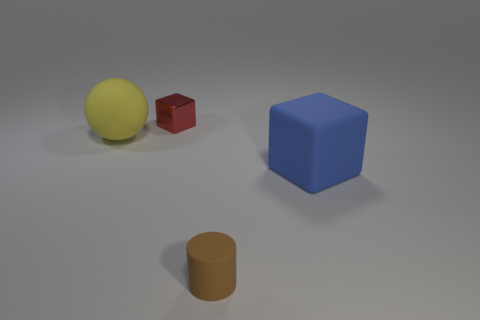Add 3 small gray shiny objects. How many objects exist? 7 Subtract all cylinders. How many objects are left? 3 Add 4 rubber blocks. How many rubber blocks are left? 5 Add 3 blue matte objects. How many blue matte objects exist? 4 Subtract 0 purple cylinders. How many objects are left? 4 Subtract all purple shiny cylinders. Subtract all spheres. How many objects are left? 3 